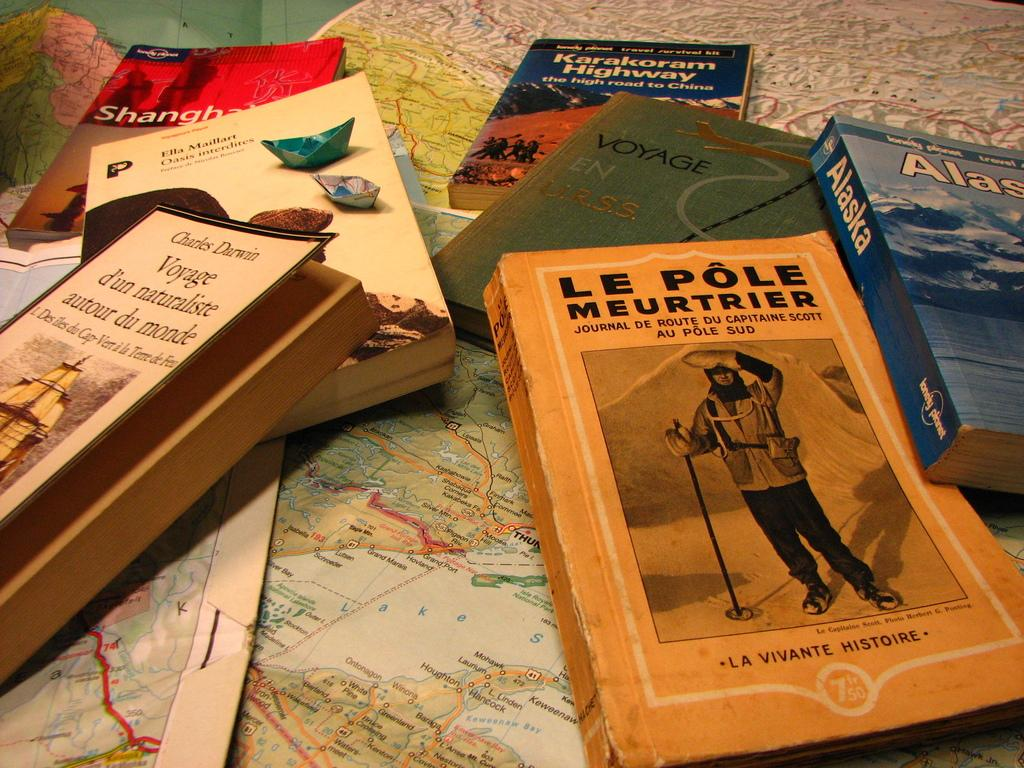<image>
Share a concise interpretation of the image provided. Several books on top of a map, including Le Pôle Meurtrier and Voyage d'un naturaliste autour du monde. 